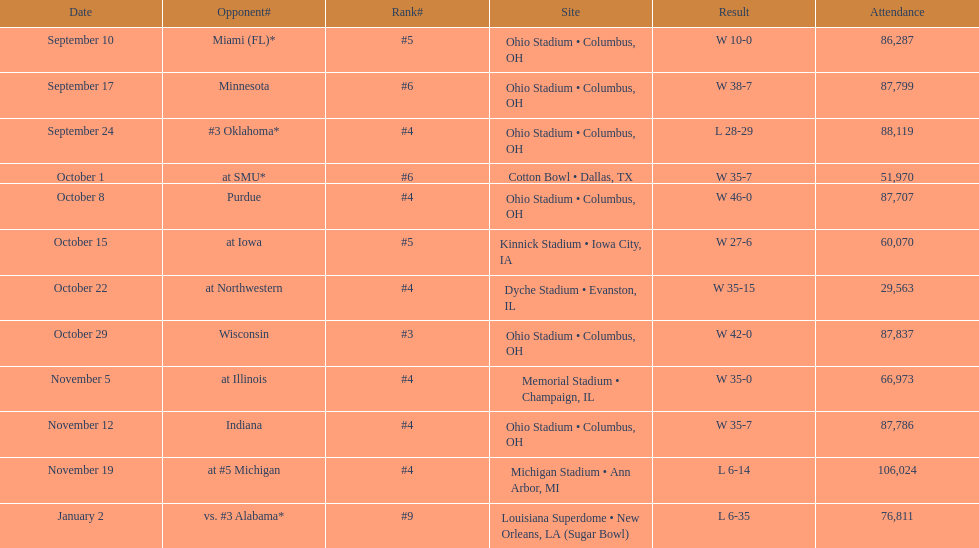Could you help me parse every detail presented in this table? {'header': ['Date', 'Opponent#', 'Rank#', 'Site', 'Result', 'Attendance'], 'rows': [['September 10', 'Miami (FL)*', '#5', 'Ohio Stadium • Columbus, OH', 'W\xa010-0', '86,287'], ['September 17', 'Minnesota', '#6', 'Ohio Stadium • Columbus, OH', 'W\xa038-7', '87,799'], ['September 24', '#3\xa0Oklahoma*', '#4', 'Ohio Stadium • Columbus, OH', 'L\xa028-29', '88,119'], ['October 1', 'at\xa0SMU*', '#6', 'Cotton Bowl • Dallas, TX', 'W\xa035-7', '51,970'], ['October 8', 'Purdue', '#4', 'Ohio Stadium • Columbus, OH', 'W\xa046-0', '87,707'], ['October 15', 'at\xa0Iowa', '#5', 'Kinnick Stadium • Iowa City, IA', 'W\xa027-6', '60,070'], ['October 22', 'at\xa0Northwestern', '#4', 'Dyche Stadium • Evanston, IL', 'W\xa035-15', '29,563'], ['October 29', 'Wisconsin', '#3', 'Ohio Stadium • Columbus, OH', 'W\xa042-0', '87,837'], ['November 5', 'at\xa0Illinois', '#4', 'Memorial Stadium • Champaign, IL', 'W\xa035-0', '66,973'], ['November 12', 'Indiana', '#4', 'Ohio Stadium • Columbus, OH', 'W\xa035-7', '87,786'], ['November 19', 'at\xa0#5\xa0Michigan', '#4', 'Michigan Stadium • Ann Arbor, MI', 'L\xa06-14', '106,024'], ['January 2', 'vs.\xa0#3\xa0Alabama*', '#9', 'Louisiana Superdome • New Orleans, LA (Sugar Bowl)', 'L\xa06-35', '76,811']]} How many dates are on the chart 12. 